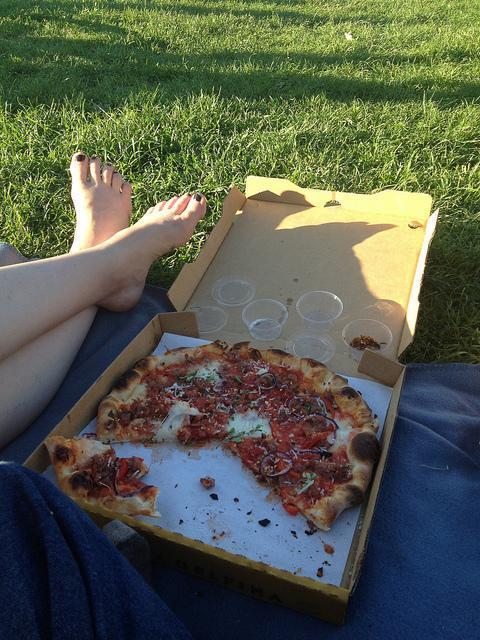How many people are in the photo?
Give a very brief answer. 2. How many pizzas are there?
Give a very brief answer. 3. How many donuts are on the plate?
Give a very brief answer. 0. 